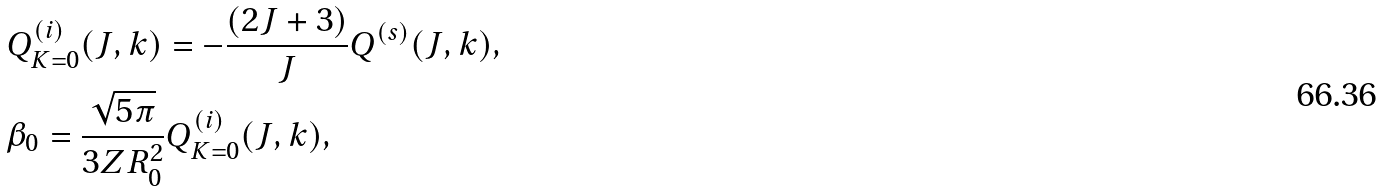Convert formula to latex. <formula><loc_0><loc_0><loc_500><loc_500>& Q ^ { ( i ) } _ { K = 0 } ( J , k ) = - \frac { ( 2 J + 3 ) } { J } Q ^ { ( s ) } ( J , k ) , \\ & \beta _ { 0 } = \frac { \sqrt { 5 \pi } } { 3 Z R _ { 0 } ^ { 2 } } Q ^ { ( i ) } _ { K = 0 } ( J , k ) ,</formula> 